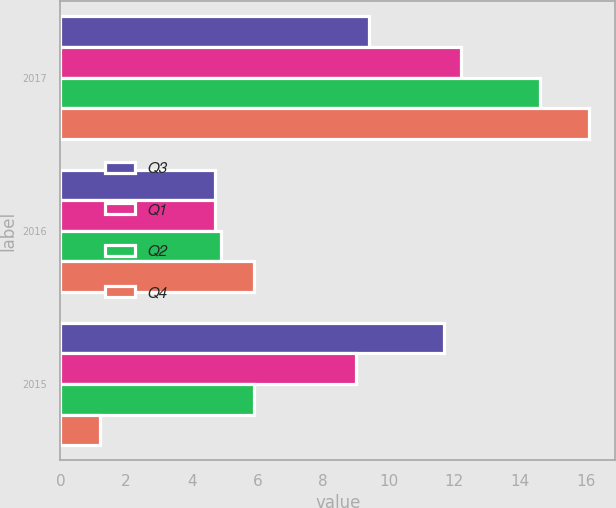Convert chart. <chart><loc_0><loc_0><loc_500><loc_500><stacked_bar_chart><ecel><fcel>2017<fcel>2016<fcel>2015<nl><fcel>Q3<fcel>9.4<fcel>4.7<fcel>11.7<nl><fcel>Q1<fcel>12.2<fcel>4.7<fcel>9<nl><fcel>Q2<fcel>14.6<fcel>4.9<fcel>5.9<nl><fcel>Q4<fcel>16.1<fcel>5.9<fcel>1.2<nl></chart> 